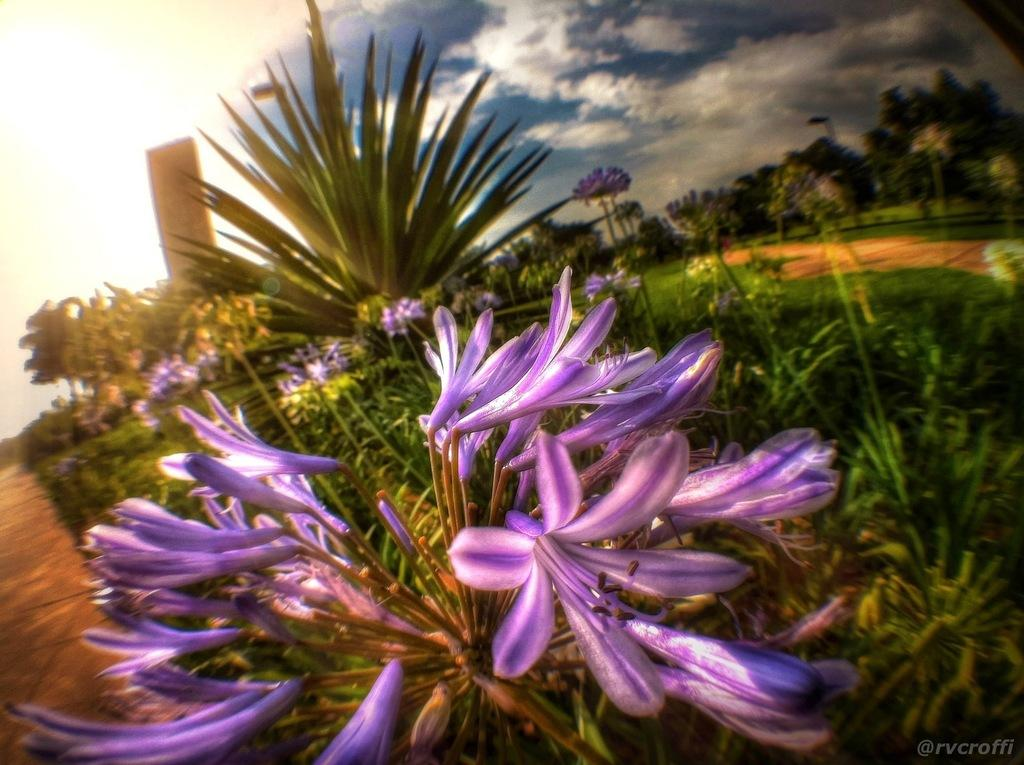What type of vegetation can be seen in the background of the image? There are flowers in the background of the image. What other natural elements are present in the image? There are trees in the image. What can be seen above the trees and flowers in the image? The sky is visible in the image. Where is the text located in the image? The text is in the bottom right corner of the image. Can you tell me how many yaks are grazing in the image? There are no yaks present in the image. Who is the writer of the text in the bottom right corner of the image? The image does not provide information about the author of the text. 